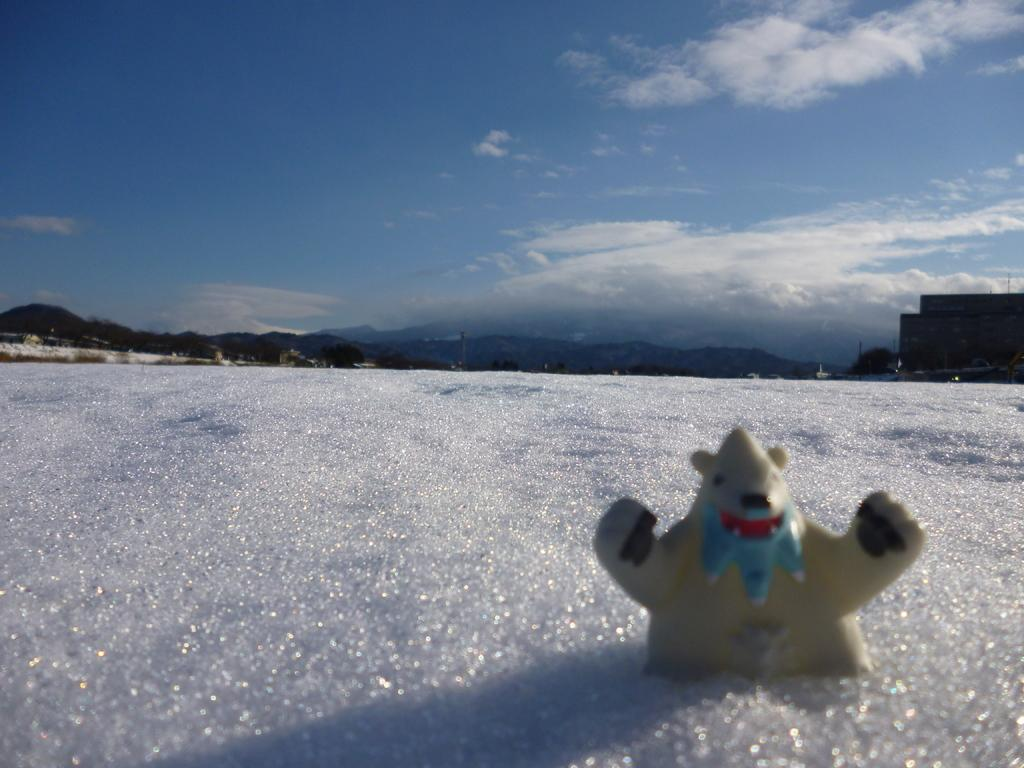What is the main subject of the image? There is a doll in the image. What is the setting of the image? The image features snow, a building, trees, hills, and a sky with clouds in the background. Can you describe the environment in the image? The environment in the image includes snow, trees, hills, and a sky with clouds. What type of structure is visible in the background? There is a building in the background of the image. What type of wine is being served at the party in the image? There is no party or wine present in the image; it features a doll in a snowy environment with a building, trees, hills, and a sky with clouds in the background. 